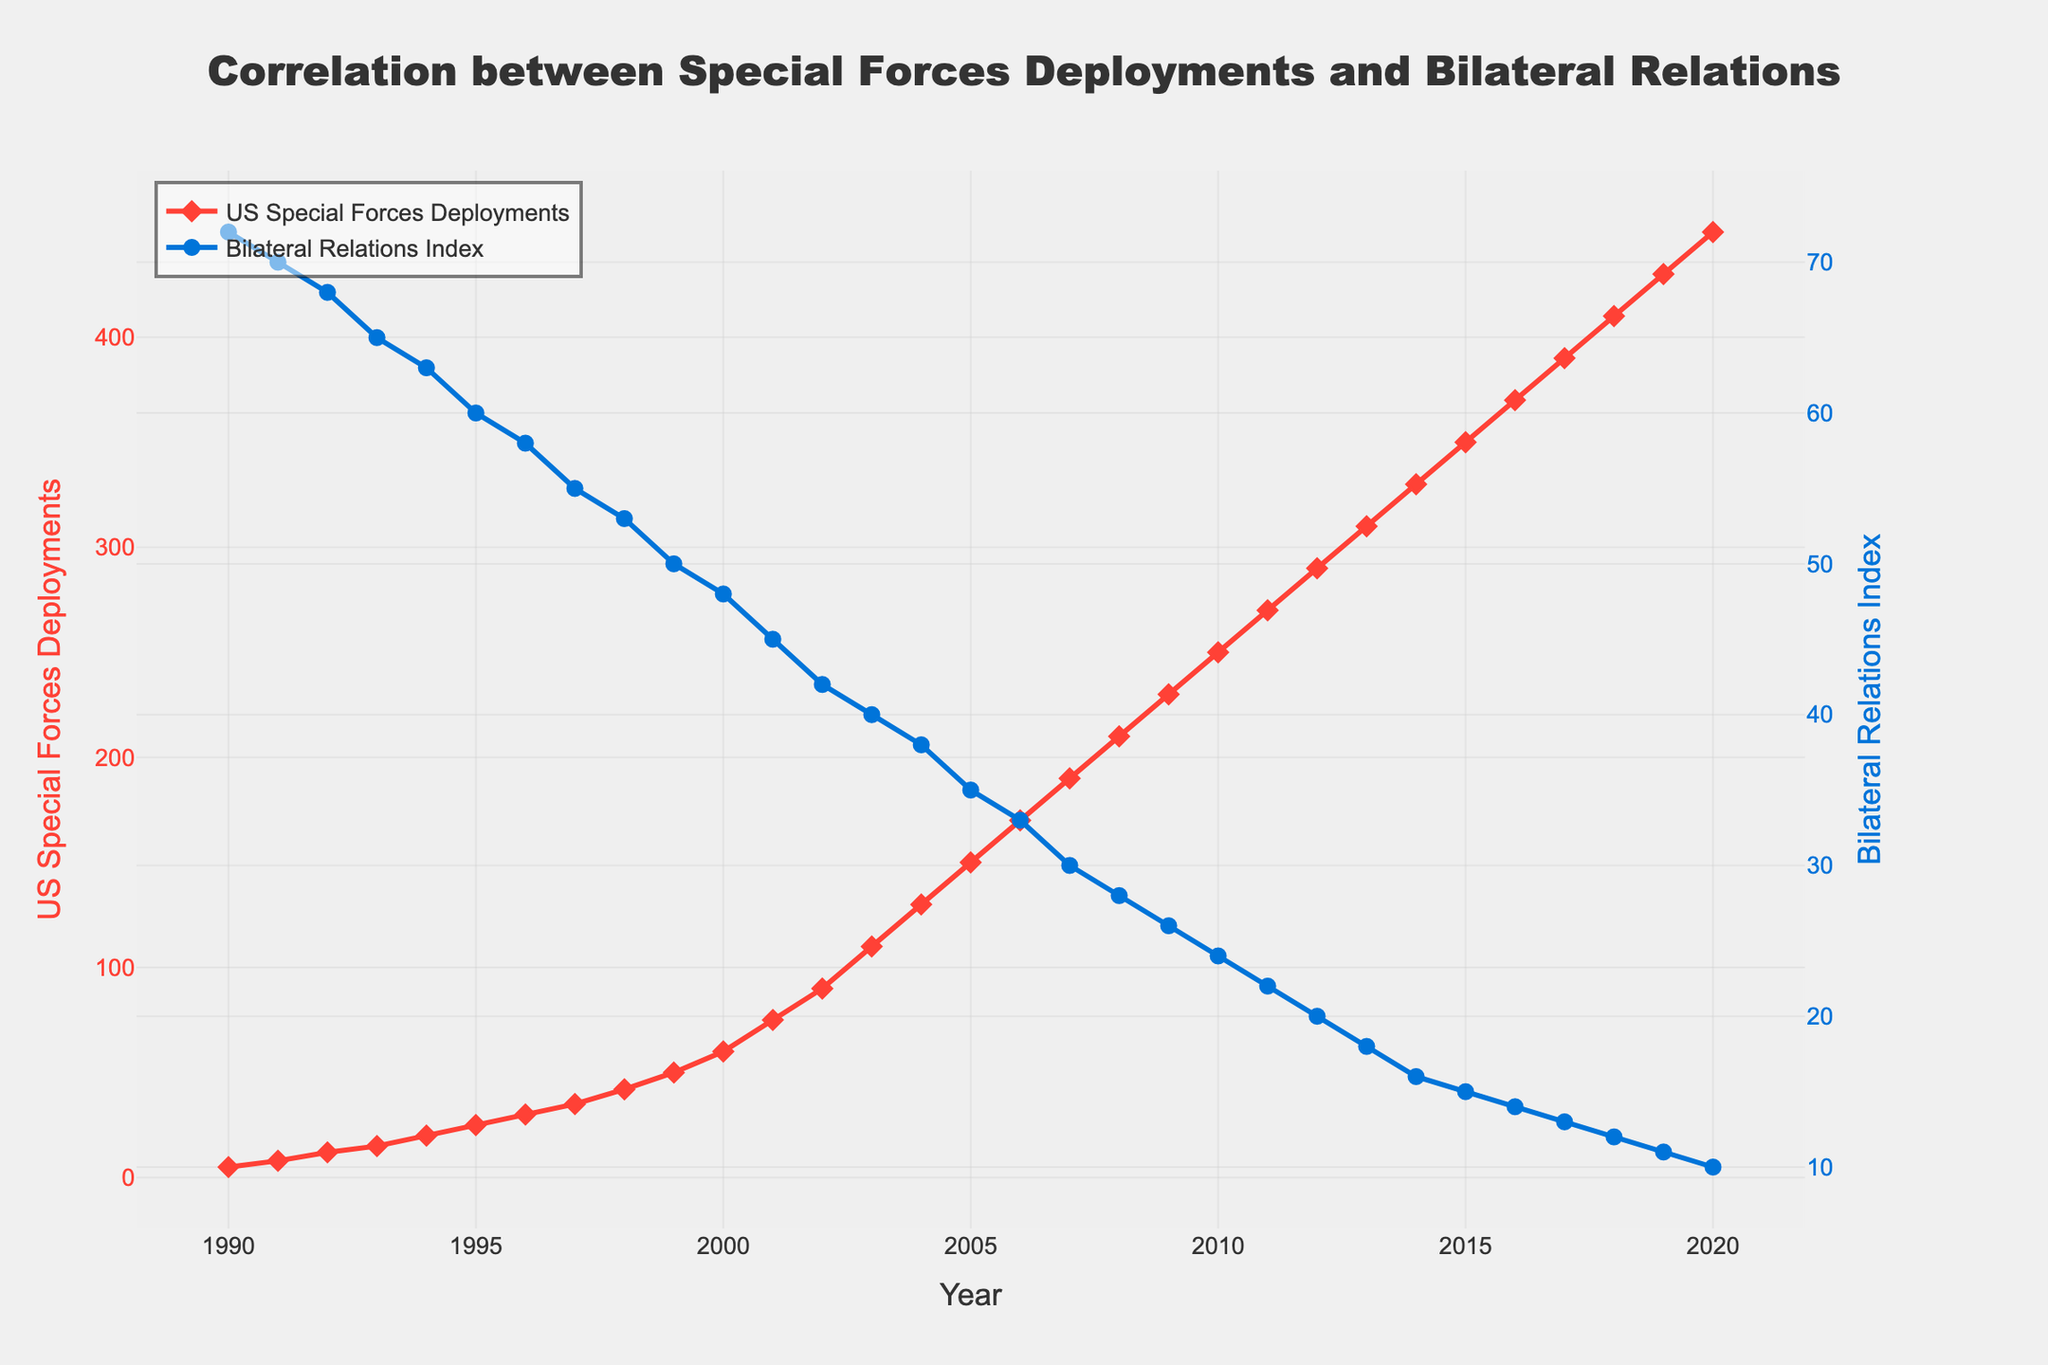1. How did the US Special Forces deployments change from 1990 to 2020? Examine the red line with diamond markers representing US Special Forces deployments. In 1990, the deployments were at 5, and in 2020, they reached 450. The change is 450 - 5 = 445.
Answer: 445 2. What was the Bilateral Relations Index in 2010, and how did it compare to the Index in 2000? Look at the blue line with circle markers. In 2010, the Bilateral Relations Index was 24, and in 2000, it was 48. The difference is 48 - 24 = 24.
Answer: 24 3. What is the general trend of the Bilateral Relations Index from 1990 to 2020? Observe the blue line with circle markers. The Bilateral Relations Index starts at 72 in 1990 and consistently decreases to 10 in 2020. This indicates a downward trend over the years.
Answer: Downward trend 4. Between which years does the US Special Forces deployment show the highest increase? To find the highest increase, check the steepest part of the red line. The largest increase occurs between 2001 (75) and 2002 (90), which is 90 - 75 = 15.
Answer: 2001 to 2002 5. How does the Bilateral Relations Index correlate with the number of special forces deployments over the chosen period? Analyze the graph to see the relationship between the two plots. As the red line (deployments) increases, the blue line (Bilateral Relations Index) decreases, indicating a negative correlation.
Answer: Negative correlation 6. What is the average US Special Forces deployments over the entire period? Sum the values of deployments from 1990 to 2020 and divide by the number of years (31). The sum is 5315, so the average is 5315 / 31.
Answer: 171.45 7. Identify the year with the lowest Bilateral Relations Index and state its value. Find the lowest point on the blue line. The lowest index is 10 in the year 2020.
Answer: 2020, 10 8. How much did the US Special Forces deployments increase between 1990 and 2000 on average per year? Calculate the change between 1990 and 2000 (60 - 5 = 55) and divide by the number of years (2000 - 1990 = 10). The average increase per year is 55 / 10.
Answer: 5.5 9. Compare the rate of deployment increase between 1990-2000 and 2000-2010. Calculate the rates for both periods. From 1990-2000, it is (60 - 5) / 10 = 5.5 per year; from 2000-2010, it is (250 - 60) / 10 = 19 per year. The rate increases faster in the second period.
Answer: Faster in 2000-2010 10. What visual characteristics make it evident that the Bilateral Relations Index and US Special Forces deployments are inversely related? Note that the red line (US Special Forces Deployments) and the blue line (Bilateral Relations Index) move in opposite directions; as the red line rises, the blue line falls, visually showing an inverse relationship.
Answer: Inverse relationship 